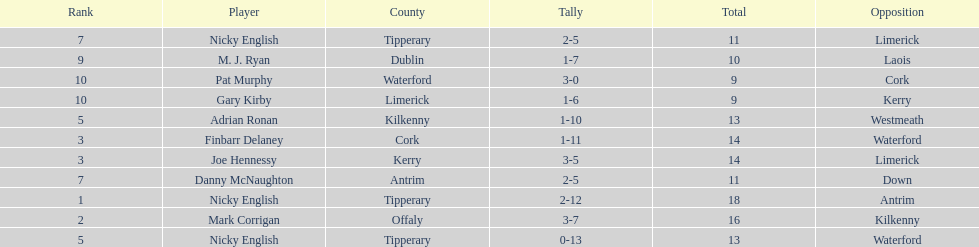What is the least total on the list? 9. 